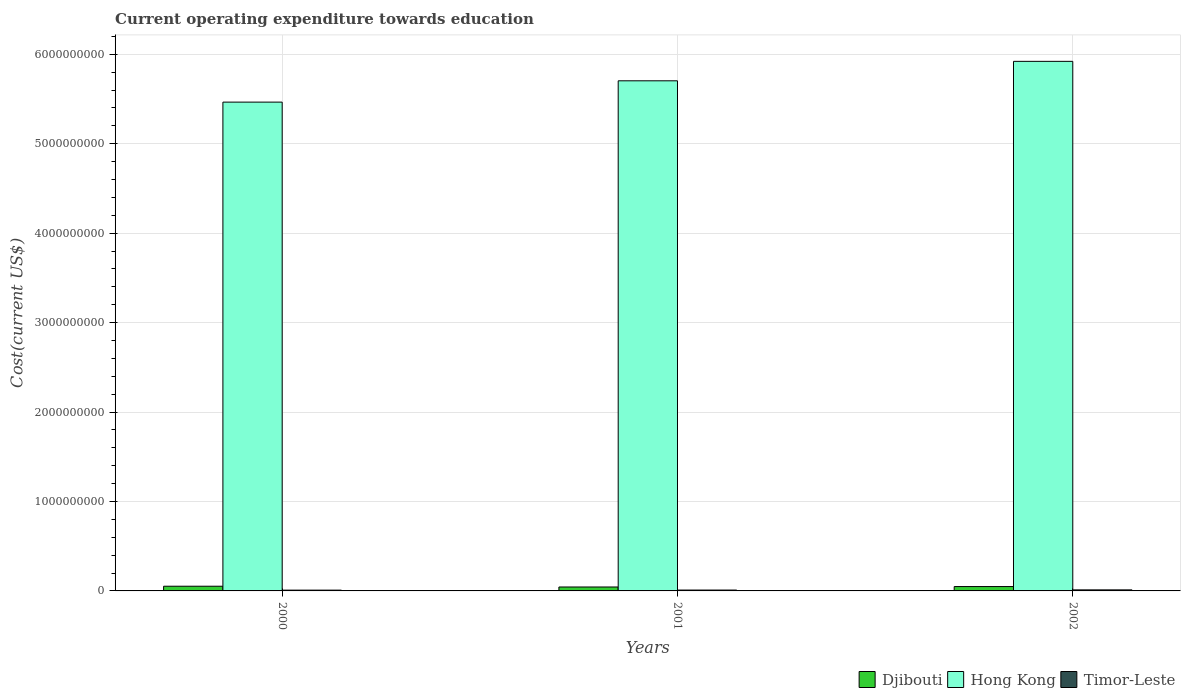How many different coloured bars are there?
Your answer should be compact. 3. Are the number of bars per tick equal to the number of legend labels?
Your response must be concise. Yes. Are the number of bars on each tick of the X-axis equal?
Ensure brevity in your answer.  Yes. How many bars are there on the 2nd tick from the left?
Give a very brief answer. 3. What is the label of the 3rd group of bars from the left?
Make the answer very short. 2002. What is the expenditure towards education in Timor-Leste in 2001?
Provide a succinct answer. 9.74e+06. Across all years, what is the maximum expenditure towards education in Djibouti?
Your answer should be very brief. 5.25e+07. Across all years, what is the minimum expenditure towards education in Timor-Leste?
Give a very brief answer. 8.85e+06. In which year was the expenditure towards education in Hong Kong maximum?
Make the answer very short. 2002. In which year was the expenditure towards education in Hong Kong minimum?
Make the answer very short. 2000. What is the total expenditure towards education in Timor-Leste in the graph?
Offer a terse response. 3.02e+07. What is the difference between the expenditure towards education in Hong Kong in 2000 and that in 2001?
Provide a succinct answer. -2.38e+08. What is the difference between the expenditure towards education in Hong Kong in 2001 and the expenditure towards education in Timor-Leste in 2002?
Offer a terse response. 5.69e+09. What is the average expenditure towards education in Djibouti per year?
Provide a short and direct response. 4.84e+07. In the year 2000, what is the difference between the expenditure towards education in Djibouti and expenditure towards education in Hong Kong?
Offer a terse response. -5.41e+09. In how many years, is the expenditure towards education in Hong Kong greater than 5200000000 US$?
Ensure brevity in your answer.  3. What is the ratio of the expenditure towards education in Hong Kong in 2001 to that in 2002?
Make the answer very short. 0.96. Is the expenditure towards education in Djibouti in 2000 less than that in 2001?
Make the answer very short. No. Is the difference between the expenditure towards education in Djibouti in 2001 and 2002 greater than the difference between the expenditure towards education in Hong Kong in 2001 and 2002?
Give a very brief answer. Yes. What is the difference between the highest and the second highest expenditure towards education in Timor-Leste?
Offer a terse response. 1.86e+06. What is the difference between the highest and the lowest expenditure towards education in Djibouti?
Your response must be concise. 8.60e+06. What does the 1st bar from the left in 2001 represents?
Give a very brief answer. Djibouti. What does the 1st bar from the right in 2000 represents?
Ensure brevity in your answer.  Timor-Leste. Are all the bars in the graph horizontal?
Offer a very short reply. No. How many years are there in the graph?
Give a very brief answer. 3. Are the values on the major ticks of Y-axis written in scientific E-notation?
Give a very brief answer. No. Does the graph contain any zero values?
Make the answer very short. No. Does the graph contain grids?
Your answer should be compact. Yes. Where does the legend appear in the graph?
Your answer should be compact. Bottom right. How are the legend labels stacked?
Your answer should be very brief. Horizontal. What is the title of the graph?
Provide a succinct answer. Current operating expenditure towards education. Does "Upper middle income" appear as one of the legend labels in the graph?
Your answer should be compact. No. What is the label or title of the X-axis?
Your answer should be very brief. Years. What is the label or title of the Y-axis?
Your answer should be very brief. Cost(current US$). What is the Cost(current US$) in Djibouti in 2000?
Provide a succinct answer. 5.25e+07. What is the Cost(current US$) of Hong Kong in 2000?
Offer a terse response. 5.47e+09. What is the Cost(current US$) of Timor-Leste in 2000?
Offer a very short reply. 8.85e+06. What is the Cost(current US$) of Djibouti in 2001?
Provide a succinct answer. 4.39e+07. What is the Cost(current US$) in Hong Kong in 2001?
Offer a very short reply. 5.70e+09. What is the Cost(current US$) in Timor-Leste in 2001?
Keep it short and to the point. 9.74e+06. What is the Cost(current US$) in Djibouti in 2002?
Ensure brevity in your answer.  4.88e+07. What is the Cost(current US$) of Hong Kong in 2002?
Offer a terse response. 5.92e+09. What is the Cost(current US$) in Timor-Leste in 2002?
Your answer should be very brief. 1.16e+07. Across all years, what is the maximum Cost(current US$) in Djibouti?
Your response must be concise. 5.25e+07. Across all years, what is the maximum Cost(current US$) in Hong Kong?
Keep it short and to the point. 5.92e+09. Across all years, what is the maximum Cost(current US$) in Timor-Leste?
Provide a short and direct response. 1.16e+07. Across all years, what is the minimum Cost(current US$) of Djibouti?
Provide a succinct answer. 4.39e+07. Across all years, what is the minimum Cost(current US$) in Hong Kong?
Your answer should be compact. 5.47e+09. Across all years, what is the minimum Cost(current US$) in Timor-Leste?
Your answer should be very brief. 8.85e+06. What is the total Cost(current US$) in Djibouti in the graph?
Make the answer very short. 1.45e+08. What is the total Cost(current US$) in Hong Kong in the graph?
Offer a very short reply. 1.71e+1. What is the total Cost(current US$) in Timor-Leste in the graph?
Make the answer very short. 3.02e+07. What is the difference between the Cost(current US$) of Djibouti in 2000 and that in 2001?
Give a very brief answer. 8.60e+06. What is the difference between the Cost(current US$) in Hong Kong in 2000 and that in 2001?
Provide a short and direct response. -2.38e+08. What is the difference between the Cost(current US$) in Timor-Leste in 2000 and that in 2001?
Provide a succinct answer. -8.85e+05. What is the difference between the Cost(current US$) in Djibouti in 2000 and that in 2002?
Make the answer very short. 3.76e+06. What is the difference between the Cost(current US$) of Hong Kong in 2000 and that in 2002?
Provide a succinct answer. -4.56e+08. What is the difference between the Cost(current US$) of Timor-Leste in 2000 and that in 2002?
Provide a succinct answer. -2.74e+06. What is the difference between the Cost(current US$) in Djibouti in 2001 and that in 2002?
Keep it short and to the point. -4.83e+06. What is the difference between the Cost(current US$) of Hong Kong in 2001 and that in 2002?
Keep it short and to the point. -2.17e+08. What is the difference between the Cost(current US$) in Timor-Leste in 2001 and that in 2002?
Give a very brief answer. -1.86e+06. What is the difference between the Cost(current US$) in Djibouti in 2000 and the Cost(current US$) in Hong Kong in 2001?
Offer a very short reply. -5.65e+09. What is the difference between the Cost(current US$) in Djibouti in 2000 and the Cost(current US$) in Timor-Leste in 2001?
Offer a terse response. 4.28e+07. What is the difference between the Cost(current US$) in Hong Kong in 2000 and the Cost(current US$) in Timor-Leste in 2001?
Give a very brief answer. 5.46e+09. What is the difference between the Cost(current US$) of Djibouti in 2000 and the Cost(current US$) of Hong Kong in 2002?
Keep it short and to the point. -5.87e+09. What is the difference between the Cost(current US$) in Djibouti in 2000 and the Cost(current US$) in Timor-Leste in 2002?
Provide a short and direct response. 4.09e+07. What is the difference between the Cost(current US$) in Hong Kong in 2000 and the Cost(current US$) in Timor-Leste in 2002?
Offer a very short reply. 5.45e+09. What is the difference between the Cost(current US$) in Djibouti in 2001 and the Cost(current US$) in Hong Kong in 2002?
Offer a terse response. -5.88e+09. What is the difference between the Cost(current US$) of Djibouti in 2001 and the Cost(current US$) of Timor-Leste in 2002?
Your answer should be very brief. 3.23e+07. What is the difference between the Cost(current US$) in Hong Kong in 2001 and the Cost(current US$) in Timor-Leste in 2002?
Your response must be concise. 5.69e+09. What is the average Cost(current US$) of Djibouti per year?
Your answer should be compact. 4.84e+07. What is the average Cost(current US$) in Hong Kong per year?
Ensure brevity in your answer.  5.70e+09. What is the average Cost(current US$) of Timor-Leste per year?
Ensure brevity in your answer.  1.01e+07. In the year 2000, what is the difference between the Cost(current US$) of Djibouti and Cost(current US$) of Hong Kong?
Ensure brevity in your answer.  -5.41e+09. In the year 2000, what is the difference between the Cost(current US$) of Djibouti and Cost(current US$) of Timor-Leste?
Your answer should be very brief. 4.37e+07. In the year 2000, what is the difference between the Cost(current US$) in Hong Kong and Cost(current US$) in Timor-Leste?
Provide a succinct answer. 5.46e+09. In the year 2001, what is the difference between the Cost(current US$) of Djibouti and Cost(current US$) of Hong Kong?
Make the answer very short. -5.66e+09. In the year 2001, what is the difference between the Cost(current US$) in Djibouti and Cost(current US$) in Timor-Leste?
Ensure brevity in your answer.  3.42e+07. In the year 2001, what is the difference between the Cost(current US$) in Hong Kong and Cost(current US$) in Timor-Leste?
Your response must be concise. 5.69e+09. In the year 2002, what is the difference between the Cost(current US$) in Djibouti and Cost(current US$) in Hong Kong?
Make the answer very short. -5.87e+09. In the year 2002, what is the difference between the Cost(current US$) of Djibouti and Cost(current US$) of Timor-Leste?
Offer a terse response. 3.72e+07. In the year 2002, what is the difference between the Cost(current US$) of Hong Kong and Cost(current US$) of Timor-Leste?
Your response must be concise. 5.91e+09. What is the ratio of the Cost(current US$) of Djibouti in 2000 to that in 2001?
Your answer should be very brief. 1.2. What is the ratio of the Cost(current US$) of Hong Kong in 2000 to that in 2001?
Make the answer very short. 0.96. What is the ratio of the Cost(current US$) in Djibouti in 2000 to that in 2002?
Provide a succinct answer. 1.08. What is the ratio of the Cost(current US$) in Hong Kong in 2000 to that in 2002?
Keep it short and to the point. 0.92. What is the ratio of the Cost(current US$) of Timor-Leste in 2000 to that in 2002?
Your answer should be very brief. 0.76. What is the ratio of the Cost(current US$) in Djibouti in 2001 to that in 2002?
Offer a terse response. 0.9. What is the ratio of the Cost(current US$) in Hong Kong in 2001 to that in 2002?
Provide a short and direct response. 0.96. What is the ratio of the Cost(current US$) in Timor-Leste in 2001 to that in 2002?
Ensure brevity in your answer.  0.84. What is the difference between the highest and the second highest Cost(current US$) in Djibouti?
Give a very brief answer. 3.76e+06. What is the difference between the highest and the second highest Cost(current US$) in Hong Kong?
Your answer should be compact. 2.17e+08. What is the difference between the highest and the second highest Cost(current US$) in Timor-Leste?
Your response must be concise. 1.86e+06. What is the difference between the highest and the lowest Cost(current US$) in Djibouti?
Ensure brevity in your answer.  8.60e+06. What is the difference between the highest and the lowest Cost(current US$) of Hong Kong?
Your answer should be very brief. 4.56e+08. What is the difference between the highest and the lowest Cost(current US$) of Timor-Leste?
Provide a short and direct response. 2.74e+06. 